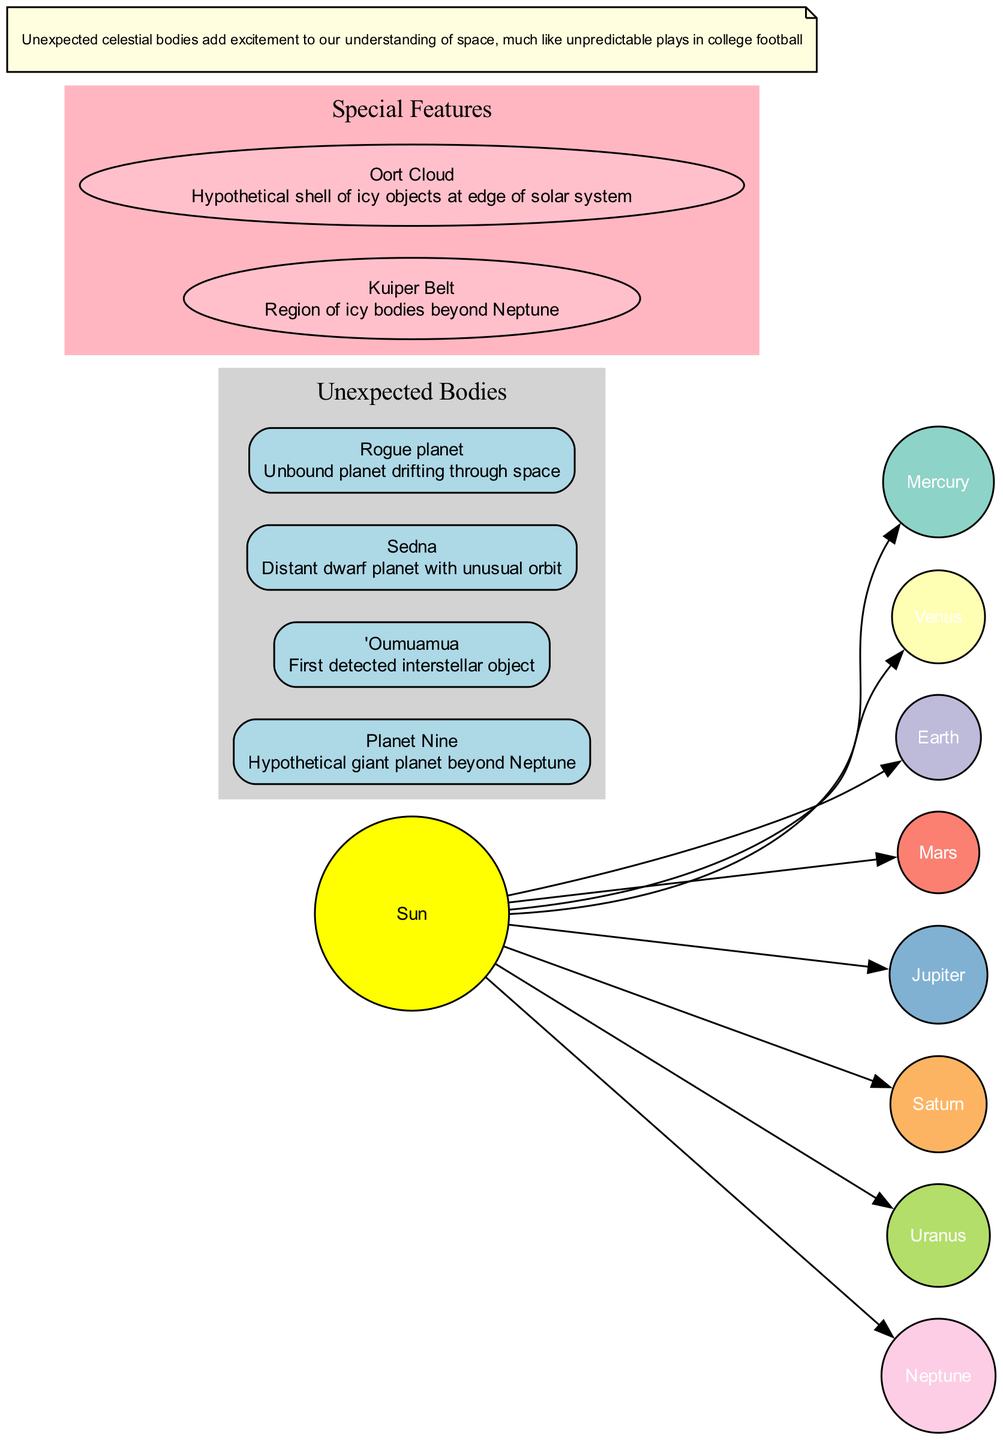What celestial object is at the center of this diagram? The diagram shows the Sun as the central node, which is explicitly labeled and depicted visually as the main source of light and energy in the solar system.
Answer: Sun How many unexpected bodies are shown in the diagram? The diagram labels and displays four unexpected bodies: Planet Nine, 'Oumuamua, Sedna, and a rogue planet. Counting them gives the total number of unexpected bodies as four.
Answer: 4 What is the description of 'Oumuamua in the diagram? The diagram details 'Oumuamua as "First detected interstellar object," which is provided in the description section associated with its node.
Answer: First detected interstellar object Which two planets are closest to the Sun based on the diagram? The diagram visually places Mercury and Venus closest to the Sun, with each planet connected directly to it via an edge, indicating their proximity in the solar system.
Answer: Mercury, Venus What feature is located beyond Neptune according to the diagram? The Kuiper Belt is indicated on the diagram as a special feature located beyond Neptune, where numerous icy bodies exist.
Answer: Kuiper Belt Which unexpected body has a hypothetical nature? The diagram describes Planet Nine as "Hypothetical giant planet beyond Neptune," denoting its speculative existence rather than confirmed observation, marking its distinction in the context.
Answer: Planet Nine How are the special features represented in the diagram? In the diagram, special features like the Kuiper Belt and Oort Cloud are represented in subgraphs labeled respectively, with shapes distinct from planet nodes, indicating their different nature within the solar system.
Answer: Special shapes and clusters What color is used for the sun in the diagram? The diagram represents the sun using a fill color that is yellow, as specified in the node attributes, visually distinguishing it from other celestial bodies.
Answer: Yellow What does the note in the diagram communicate? The note at the bottom of the diagram succinctly states that "Unexpected celestial bodies add excitement to our understanding of space, much like unpredictable plays in college football," relating the unpredictability of cosmic bodies to college football excitement.
Answer: Unexpected celestial bodies add excitement to our understanding of space, much like unpredictable plays in college football 